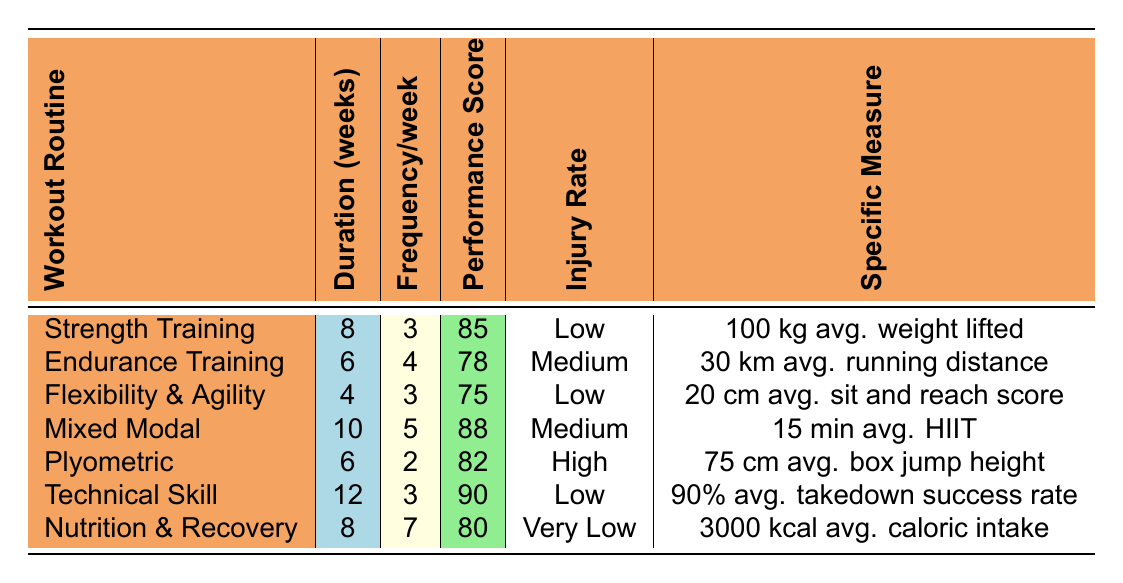What is the performance measure score for Strength Training? The table lists "Strength Training" with a performance measure score of 85. This is a direct retrieval from the performance score column.
Answer: 85 How many weeks does the Mixed Modal Training last? The information in the table states that Mixed Modal Training lasts for 10 weeks. This data point is retrieved from the duration column.
Answer: 10 Which workout routine has the lowest injury incidence rate? By comparing the injury incidence rates listed, "Nutrition and Recovery Focus" has a "very low" incidence rate, which is lower than all others. Thus, it is determined as having the lowest injury incidence rate.
Answer: Nutrition and Recovery Focus What is the average performance score of all workout routines listed? To find the average performance score, we first sum the performance scores: 85 + 78 + 75 + 88 + 82 + 90 + 80 = 528. There are 7 routines, so the average is 528/7 = approximately 75.429 or about 75.43 if rounding to two decimal places.
Answer: 75.43 Is it true or false that Flexibility and Agility Drills have a higher performance measure score than Endurance Training? The performance measure score for Flexibility and Agility is 75, while Endurance Training's score is 78. Since 75 is less than 78, the statement is false.
Answer: False How does the frequency of Technical Skill Training compare to Plyometric Training? Technical Skill Training occurs 3 times a week, and Plyometric Training occurs 2 times a week. 3 is greater than 2, indicating that Technical Skill Training has a higher frequency than Plyometric Training.
Answer: Technical Skill Training has a higher frequency What is the difference in performance measure scores between Mixed Modal Training and Plyometric Training? Mixed Modal Training has a performance measure score of 88 and Plyometric Training has a score of 82. The difference is 88 - 82 = 6.
Answer: 6 Which routine has the highest average weight lifted? Looking at the specific measures, "Strength Training" reports an average weight lifted of 100 kg, which is the highest among all listed workout routines.
Answer: Strength Training How many training routines have a performance measure score of 80 or higher? The routines with scores of 80 or higher are Strength Training (85), Mixed Modal Training (88), Technical Skill Training (90), and Nutrition and Recovery Focus (80). Counting these provides 4 routines with scores of 80 or higher.
Answer: 4 